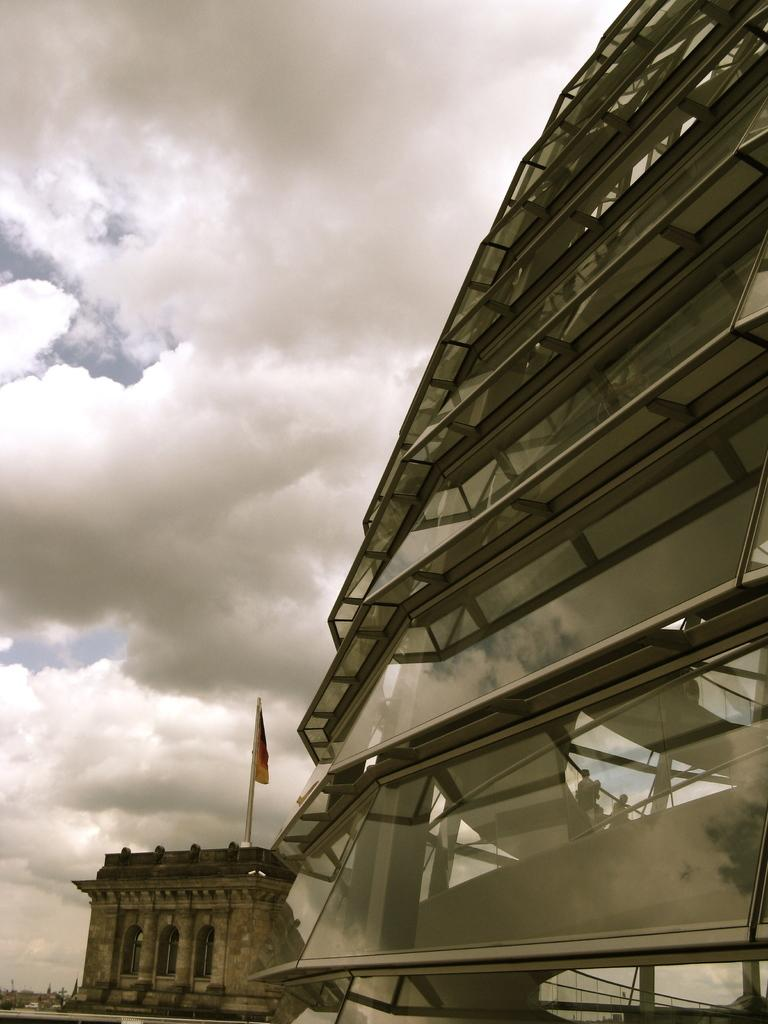How many buildings can be seen in the image? There are two buildings in the image. What is located in the middle of the image? There is a flag in the middle of the image. What objects are on the right side of the image? There are glasses on the right side of the image. What is visible at the top of the image? The sky is visible at the top of the image. What can be observed in the sky? Clouds are present in the sky. What statement does the bike make in the image? There is no bike present in the image, so it cannot make any statement. What need does the flag fulfill in the image? The flag does not fulfill a specific need in the image; it is simply a decorative or symbolic element. 